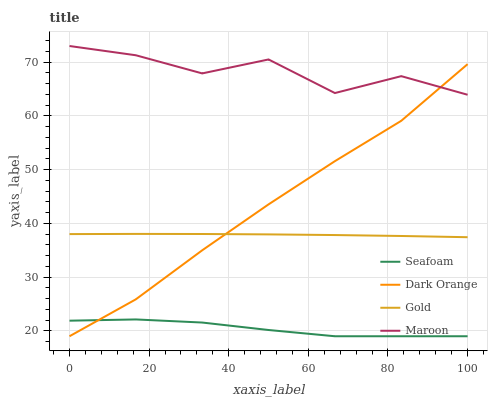Does Seafoam have the minimum area under the curve?
Answer yes or no. Yes. Does Maroon have the maximum area under the curve?
Answer yes or no. Yes. Does Dark Orange have the minimum area under the curve?
Answer yes or no. No. Does Dark Orange have the maximum area under the curve?
Answer yes or no. No. Is Gold the smoothest?
Answer yes or no. Yes. Is Maroon the roughest?
Answer yes or no. Yes. Is Dark Orange the smoothest?
Answer yes or no. No. Is Dark Orange the roughest?
Answer yes or no. No. Does Dark Orange have the lowest value?
Answer yes or no. Yes. Does Gold have the lowest value?
Answer yes or no. No. Does Maroon have the highest value?
Answer yes or no. Yes. Does Dark Orange have the highest value?
Answer yes or no. No. Is Seafoam less than Gold?
Answer yes or no. Yes. Is Maroon greater than Seafoam?
Answer yes or no. Yes. Does Dark Orange intersect Gold?
Answer yes or no. Yes. Is Dark Orange less than Gold?
Answer yes or no. No. Is Dark Orange greater than Gold?
Answer yes or no. No. Does Seafoam intersect Gold?
Answer yes or no. No. 